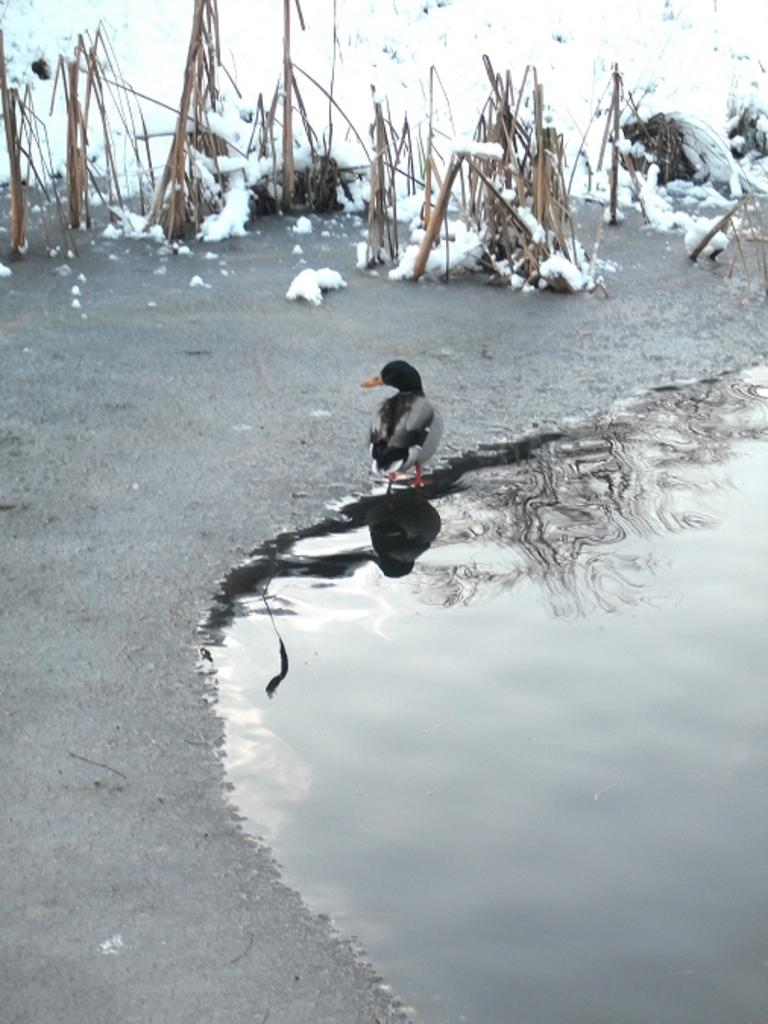What is the main subject in the center of the image? There is a duck in the center of the image. What can be seen on the right side of the image? There is water on the right side of the image. What type of weather condition is depicted at the top side of the image? There is snow at the top side of the image. What role does the father play in the image? There is no mention of a father or any human presence in the image; it primarily features a duck and its surroundings. 